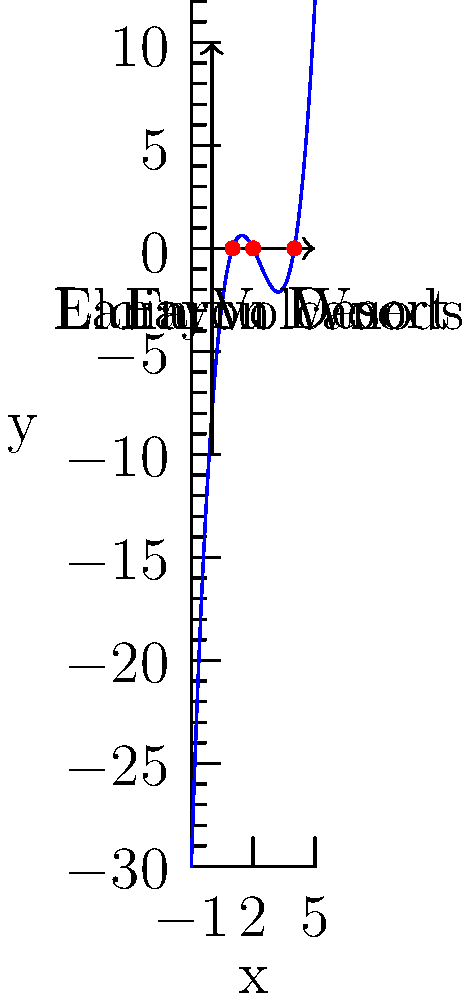In The Legend of Zelda: Skyward Sword, the locations of the three Sacred Flames are represented by the roots of a polynomial equation. Given that the polynomial $f(x) = x^3 - 7x^2 + 14x - 8$ models the locations, determine the x-coordinates of the Sacred Flames and match them to their corresponding regions: Eldin Volcano, Lanayru Desert, and Faron Woods. To solve this problem, we need to follow these steps:

1) First, we need to find the roots of the polynomial equation $f(x) = x^3 - 7x^2 + 14x - 8 = 0$.

2) We can factor this polynomial:
   $f(x) = (x-1)(x-2)(x-4) = 0$

3) The roots of this equation are $x = 1$, $x = 2$, and $x = 4$.

4) Now, we need to match these roots to the locations in Skyward Sword:

   - The smallest root (1) corresponds to Eldin Volcano, as it's typically the first Sacred Flame location visited.
   - The middle root (2) corresponds to Lanayru Desert, usually the second location.
   - The largest root (4) corresponds to Faron Woods, typically the last location visited.

5) Therefore, the Sacred Flames are located at:
   - Eldin Volcano: x = 1
   - Lanayru Desert: x = 2
   - Faron Woods: x = 4

This matches the labeling in the graph, where we can see the roots plotted as red dots on the x-axis.
Answer: Eldin Volcano (1), Lanayru Desert (2), Faron Woods (4) 